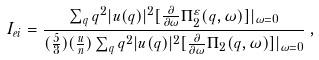<formula> <loc_0><loc_0><loc_500><loc_500>I _ { e i } = \frac { \sum _ { q } q ^ { 2 } | u ( { q } ) | ^ { 2 } [ \frac { \partial } { \partial \omega } \Pi _ { 2 } ^ { \varepsilon } ( { q } , \omega ) ] | _ { \omega = 0 } } { ( \frac { 5 } { 3 } ) ( \frac { u } { n } ) \sum _ { q } q ^ { 2 } | u ( { q } ) | ^ { 2 } [ \frac { \partial } { \partial \omega } \Pi _ { 2 } ( { q } , \omega ) ] | _ { \omega = 0 } } \, ,</formula> 